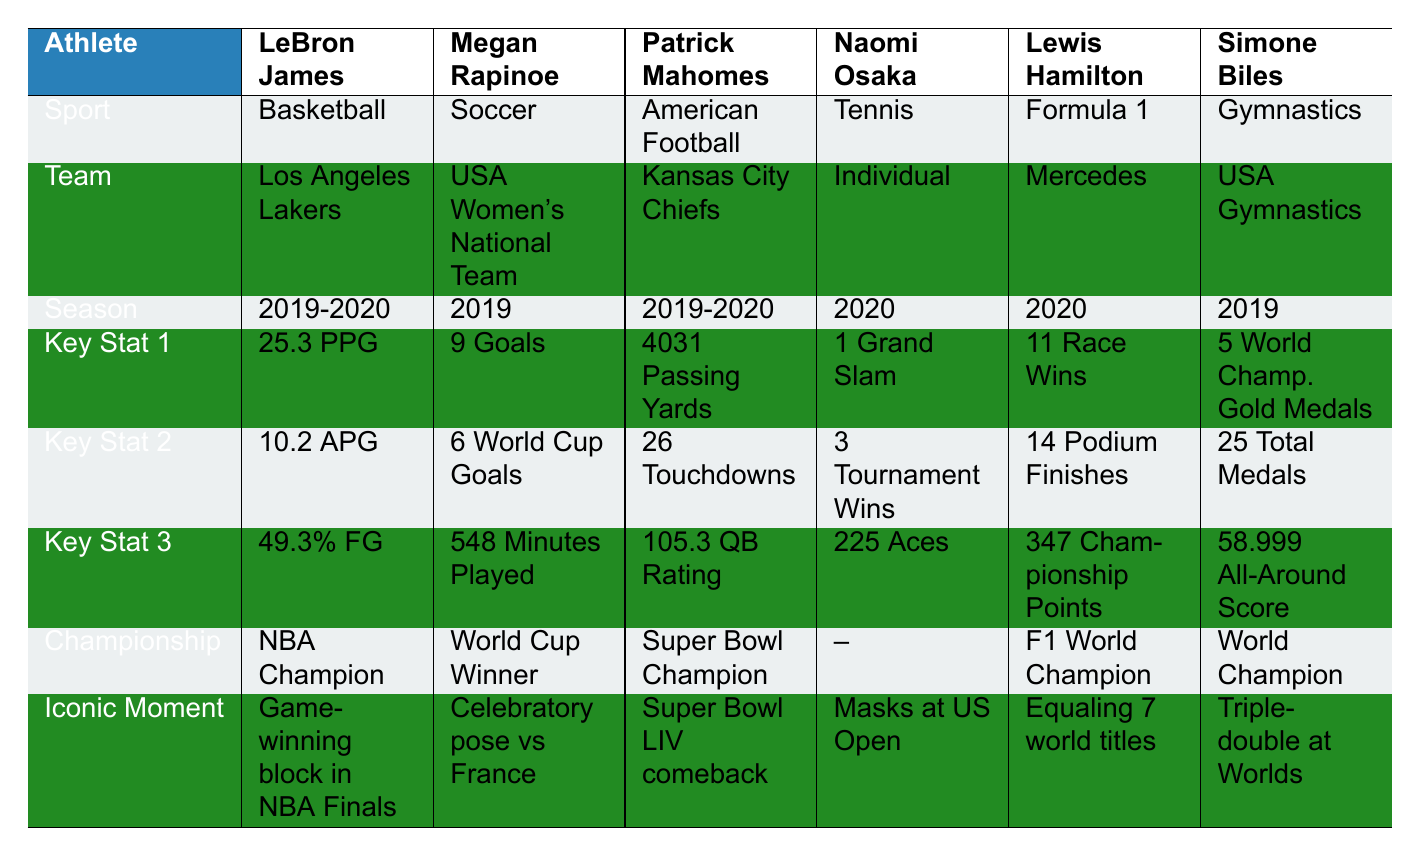What sport does LeBron James play? The table lists LeBron James under the "Sport" section where it indicates he plays Basketball.
Answer: Basketball How many goals did Megan Rapinoe score in the World Cup? The table specifies that Megan Rapinoe scored 6 goals in the World Cup under the "Key Stat 2" section.
Answer: 6 goals Which athlete had the highest passing yards during the championship season? The table shows Patrick Mahomes with 4031 passing yards, which is greater than any other athlete listed.
Answer: Patrick Mahomes Is Lewis Hamilton a world champion? The table includes a "Championship" section indicating that Lewis Hamilton is indeed a World Champion.
Answer: Yes What is the average rebounds per game for LeBron James? The table lists LeBron James with 7.8 rebounds per game. There are no other players in basketball to average here, so the average is his total.
Answer: 7.8 How many total medals did Simone Biles win? The table reflects that Simone Biles won a total of 25 medals in her championship season under the “Key Stat 2” section.
Answer: 25 medals Who had the most race wins among the athletes listed? According to the table, Lewis Hamilton had 11 race wins, which is the highest compared to others.
Answer: Lewis Hamilton Did Naomi Osaka win a Grand Slam title in her championship season? The table indicates under the "Key Stat 1" section that Naomi Osaka won 1 Grand Slam title, affirming that she did win one.
Answer: Yes How many athletes represented teams in their championship seasons? The table shows that most athletes are associated with teams, specifically LeBron James, Megan Rapinoe, Patrick Mahomes, Lewis Hamilton, and Simone Biles, totaling 5 out of 6.
Answer: 5 athletes What is the combined number of touchdowns and playoff touchdowns for Patrick Mahomes? To find the combined number, add Patrick Mahomes' touchdowns (26) to his playoff touchdowns (10) to get 36.
Answer: 36 What is Simone Biles' average score on the vault? The table lists her average score on the vault as 15.399, which is her performance metric.
Answer: 15.399 Which player had the most assists per game in their championship season? LeBron James had 10.2 assists per game, which is the highest number compared to the statistics of other players in the table.
Answer: LeBron James Which athlete achieved the title of Super Bowl MVP? The table clearly states that Patrick Mahomes was recognized as the Super Bowl MVP, confirming he received this honor.
Answer: Patrick Mahomes What is the iconic moment for Megan Rapinoe during her championship season? The table includes a specific detail that her iconic moment was posing after scoring against France in the World Cup quarterfinals.
Answer: Celebratory pose vs France How many more podium finishes did Lewis Hamilton have compared to race wins? Lewis Hamilton had 14 podium finishes and 11 race wins. The difference is 14 - 11 = 3 more podium finishes.
Answer: 3 podium finishes Who displayed activism during their championship season, and what was their iconic moment? The table indicates that Naomi Osaka displayed activism by wearing masks with names of police brutality victims at the US Open as her iconic moment.
Answer: Naomi Osaka, masks at US Open 